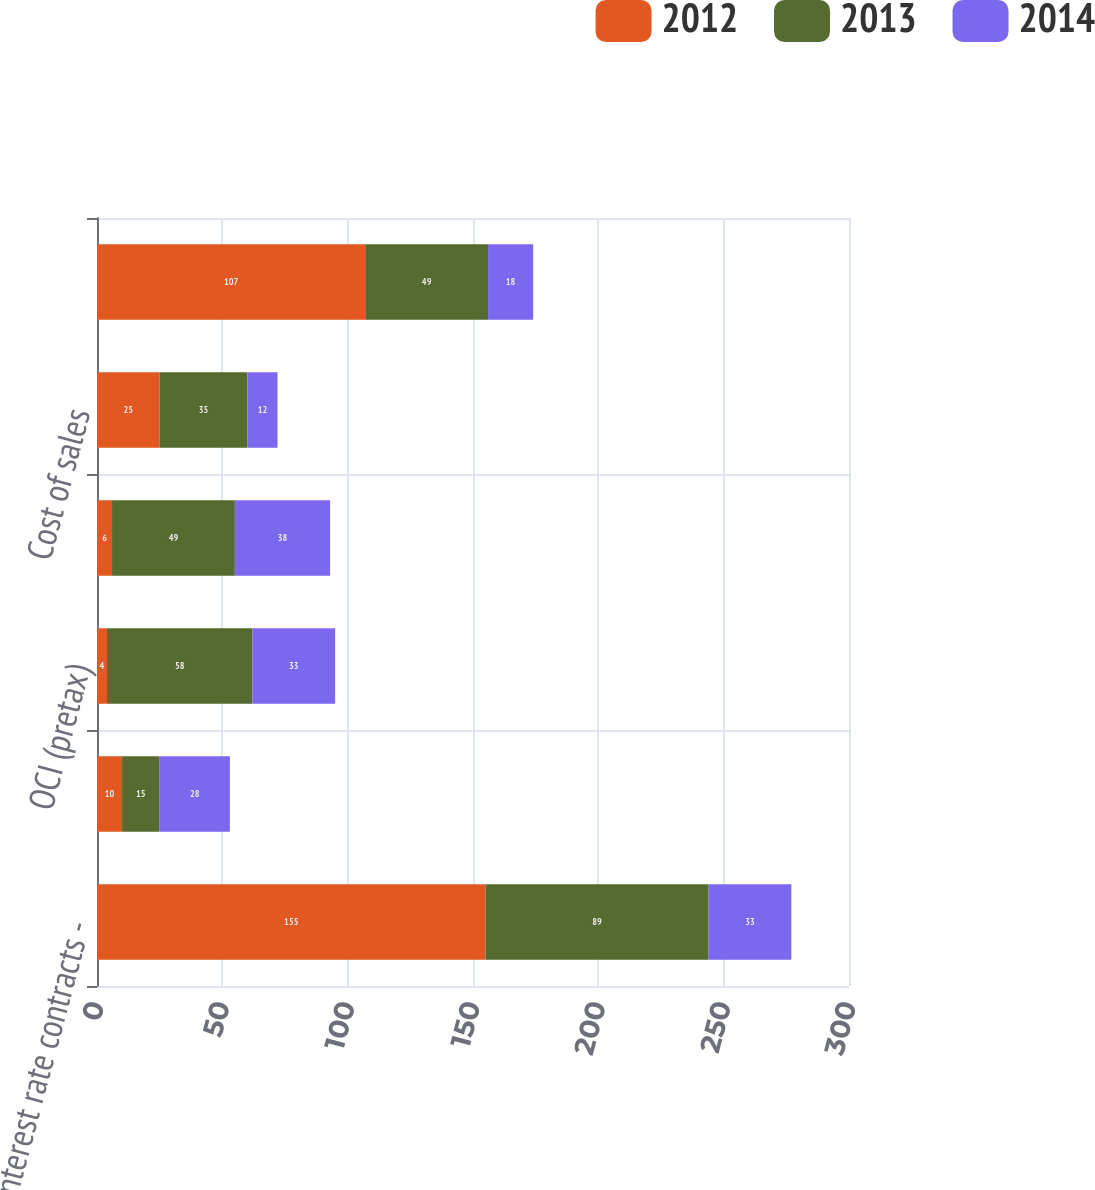Convert chart to OTSL. <chart><loc_0><loc_0><loc_500><loc_500><stacked_bar_chart><ecel><fcel>Interest rate contracts -<fcel>Interest rate contracts - OCI<fcel>OCI (pretax)<fcel>Other expense<fcel>Cost of sales<fcel>Total not designated<nl><fcel>2012<fcel>155<fcel>10<fcel>4<fcel>6<fcel>25<fcel>107<nl><fcel>2013<fcel>89<fcel>15<fcel>58<fcel>49<fcel>35<fcel>49<nl><fcel>2014<fcel>33<fcel>28<fcel>33<fcel>38<fcel>12<fcel>18<nl></chart> 